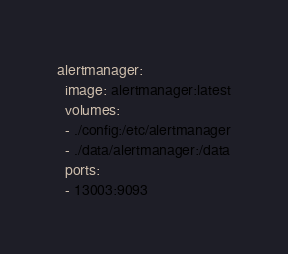<code> <loc_0><loc_0><loc_500><loc_500><_YAML_>alertmanager:
  image: alertmanager:latest
  volumes:
  - ./config:/etc/alertmanager
  - ./data/alertmanager:/data
  ports:
  - 13003:9093
</code> 